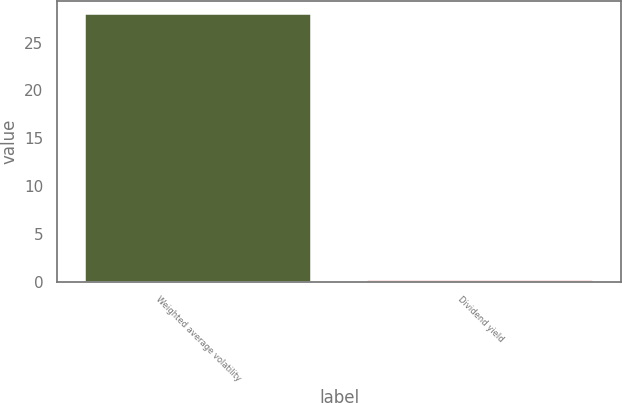<chart> <loc_0><loc_0><loc_500><loc_500><bar_chart><fcel>Weighted average volatility<fcel>Dividend yield<nl><fcel>28<fcel>0.2<nl></chart> 